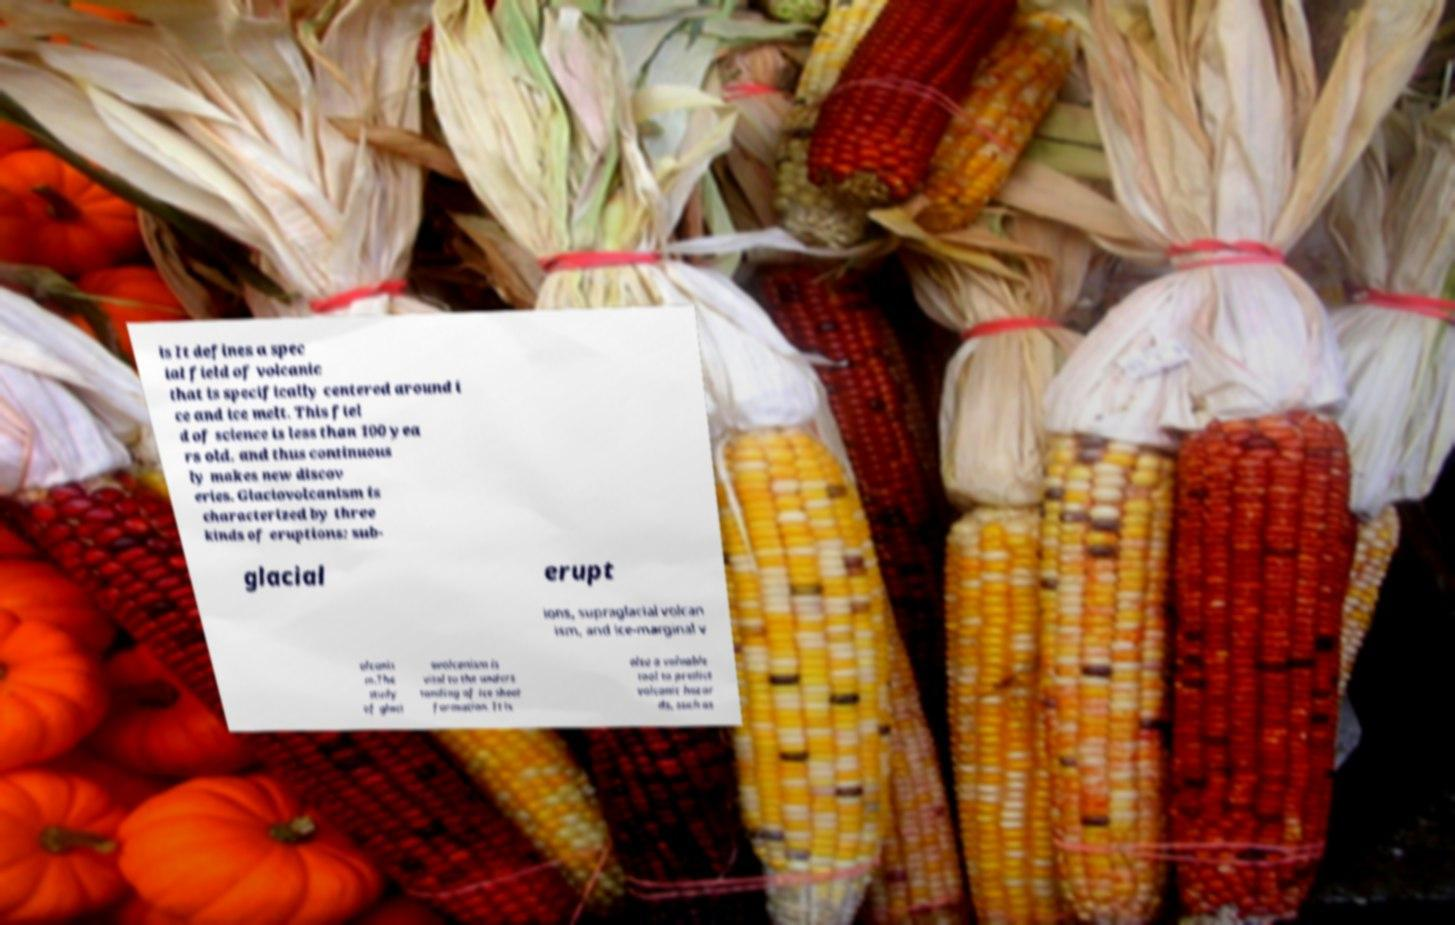For documentation purposes, I need the text within this image transcribed. Could you provide that? is It defines a spec ial field of volcanic that is specifically centered around i ce and ice melt. This fiel d of science is less than 100 yea rs old, and thus continuous ly makes new discov eries. Glaciovolcanism is characterized by three kinds of eruptions: sub- glacial erupt ions, supraglacial volcan ism, and ice-marginal v olcanis m.The study of glaci ovolcanism is vital to the unders tanding of ice sheet formation. It is also a valuable tool to predict volcanic hazar ds, such as 